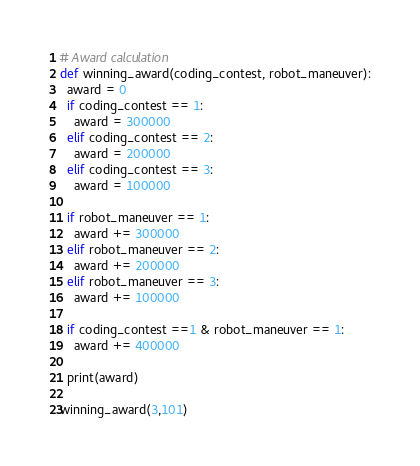<code> <loc_0><loc_0><loc_500><loc_500><_Python_># Award calculation
def winning_award(coding_contest, robot_maneuver):
  award = 0
  if coding_contest == 1:
    award = 300000
  elif coding_contest == 2:
    award = 200000
  elif coding_contest == 3:
    award = 100000

  if robot_maneuver == 1:
    award += 300000
  elif robot_maneuver == 2:
    award += 200000
  elif robot_maneuver == 3:
    award += 100000

  if coding_contest ==1 & robot_maneuver == 1:
    award += 400000

  print(award)

winning_award(3,101)</code> 